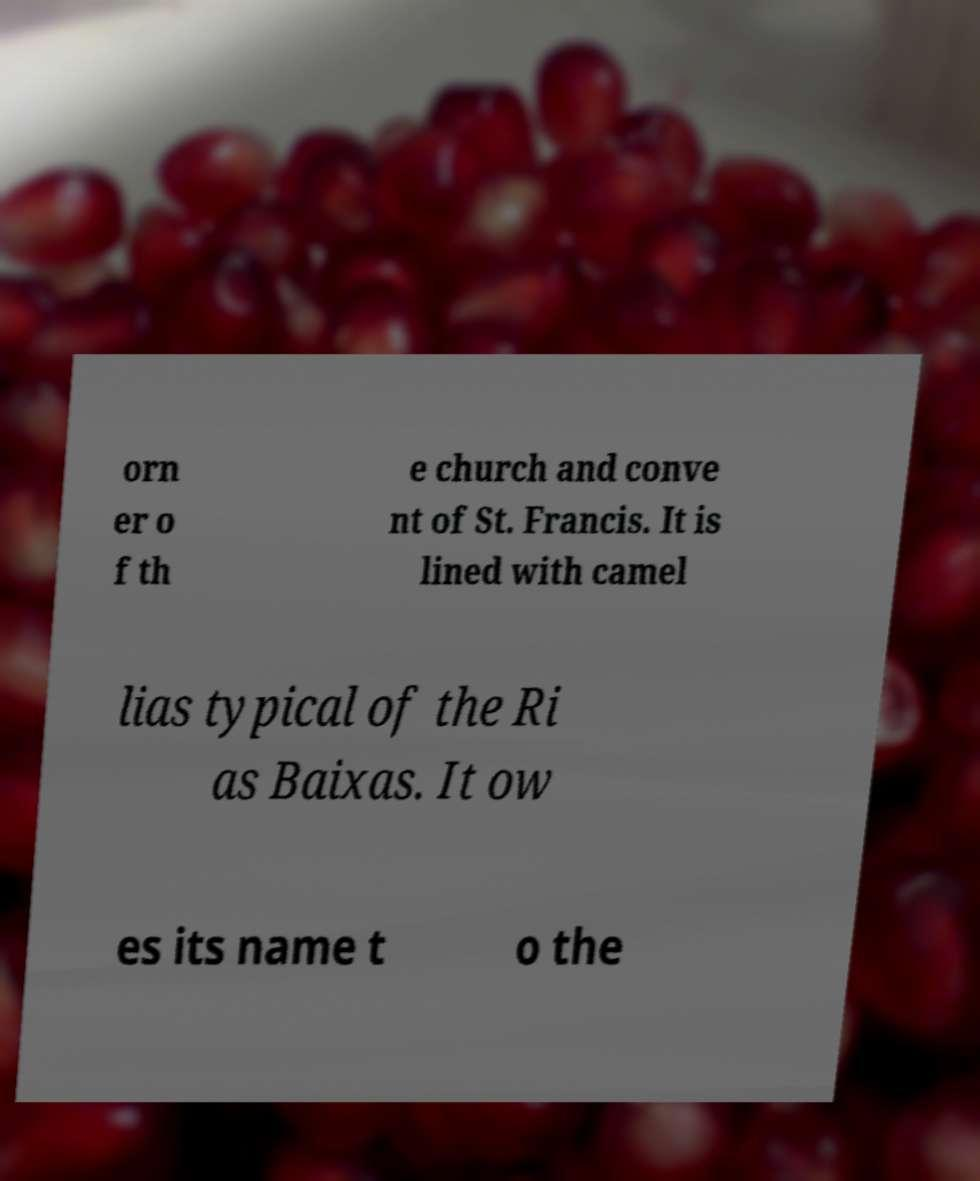What messages or text are displayed in this image? I need them in a readable, typed format. orn er o f th e church and conve nt of St. Francis. It is lined with camel lias typical of the Ri as Baixas. It ow es its name t o the 